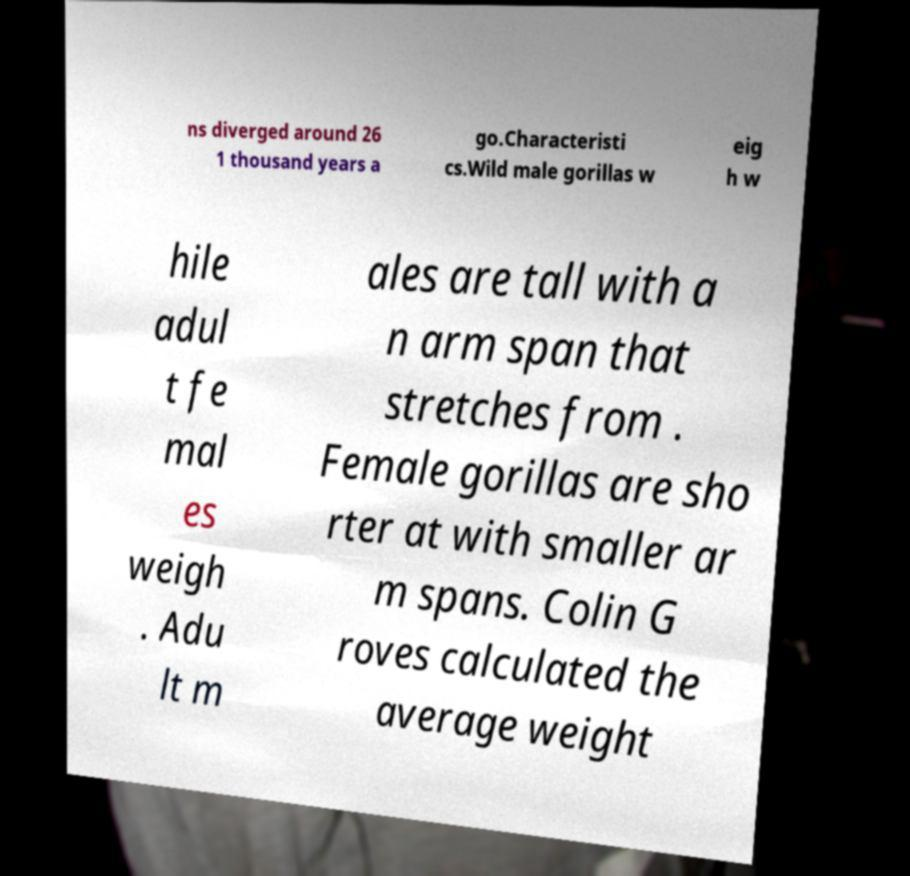Can you read and provide the text displayed in the image?This photo seems to have some interesting text. Can you extract and type it out for me? ns diverged around 26 1 thousand years a go.Characteristi cs.Wild male gorillas w eig h w hile adul t fe mal es weigh . Adu lt m ales are tall with a n arm span that stretches from . Female gorillas are sho rter at with smaller ar m spans. Colin G roves calculated the average weight 